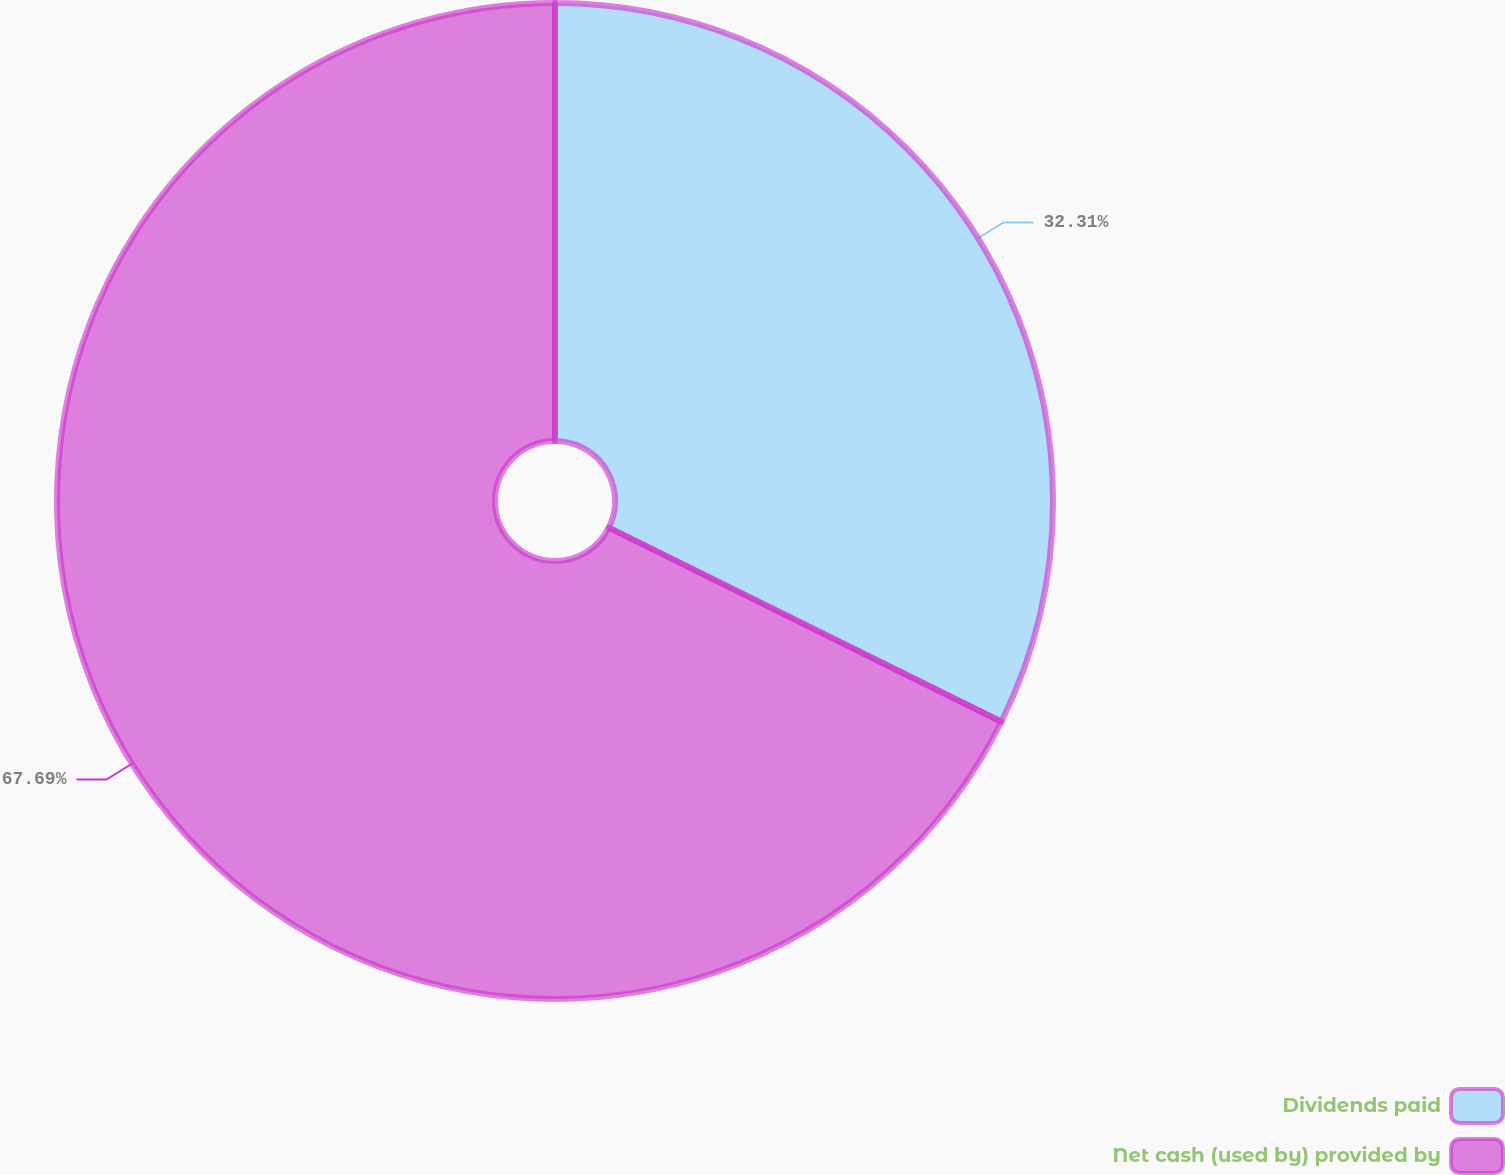Convert chart to OTSL. <chart><loc_0><loc_0><loc_500><loc_500><pie_chart><fcel>Dividends paid<fcel>Net cash (used by) provided by<nl><fcel>32.31%<fcel>67.69%<nl></chart> 